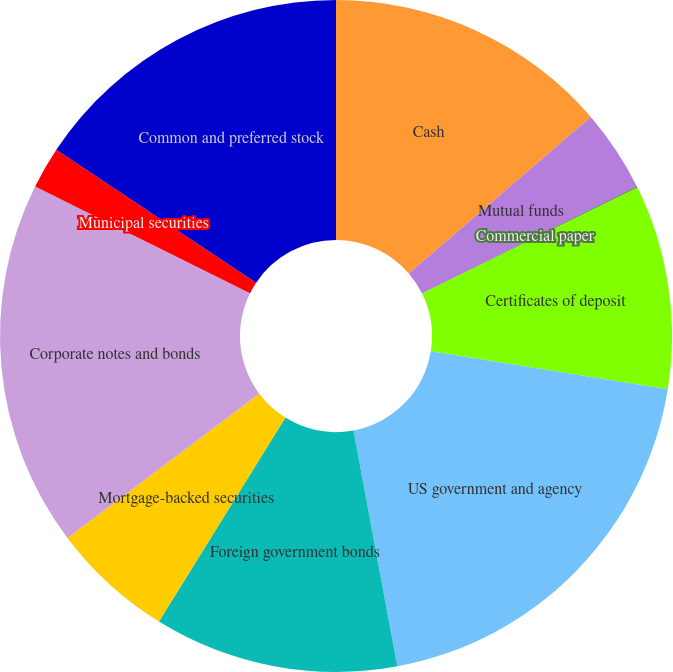Convert chart. <chart><loc_0><loc_0><loc_500><loc_500><pie_chart><fcel>Cash<fcel>Mutual funds<fcel>Commercial paper<fcel>Certificates of deposit<fcel>US government and agency<fcel>Foreign government bonds<fcel>Mortgage-backed securities<fcel>Corporate notes and bonds<fcel>Municipal securities<fcel>Common and preferred stock<nl><fcel>13.7%<fcel>3.96%<fcel>0.06%<fcel>9.81%<fcel>19.55%<fcel>11.75%<fcel>5.91%<fcel>17.6%<fcel>2.01%<fcel>15.65%<nl></chart> 